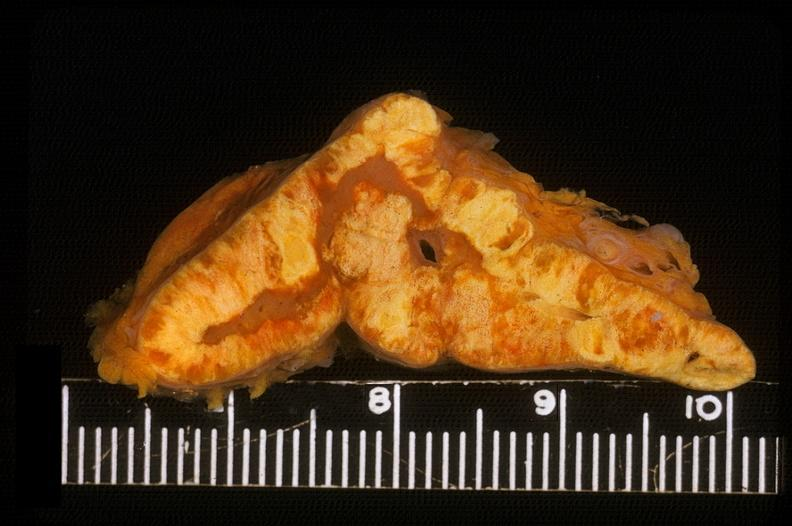does this image show adrenal, cortical hyperplasia?
Answer the question using a single word or phrase. Yes 